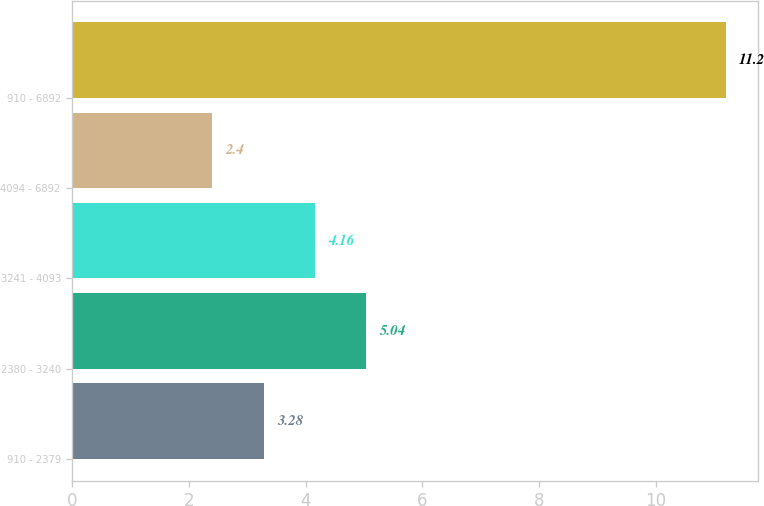<chart> <loc_0><loc_0><loc_500><loc_500><bar_chart><fcel>910 - 2379<fcel>2380 - 3240<fcel>3241 - 4093<fcel>4094 - 6892<fcel>910 - 6892<nl><fcel>3.28<fcel>5.04<fcel>4.16<fcel>2.4<fcel>11.2<nl></chart> 